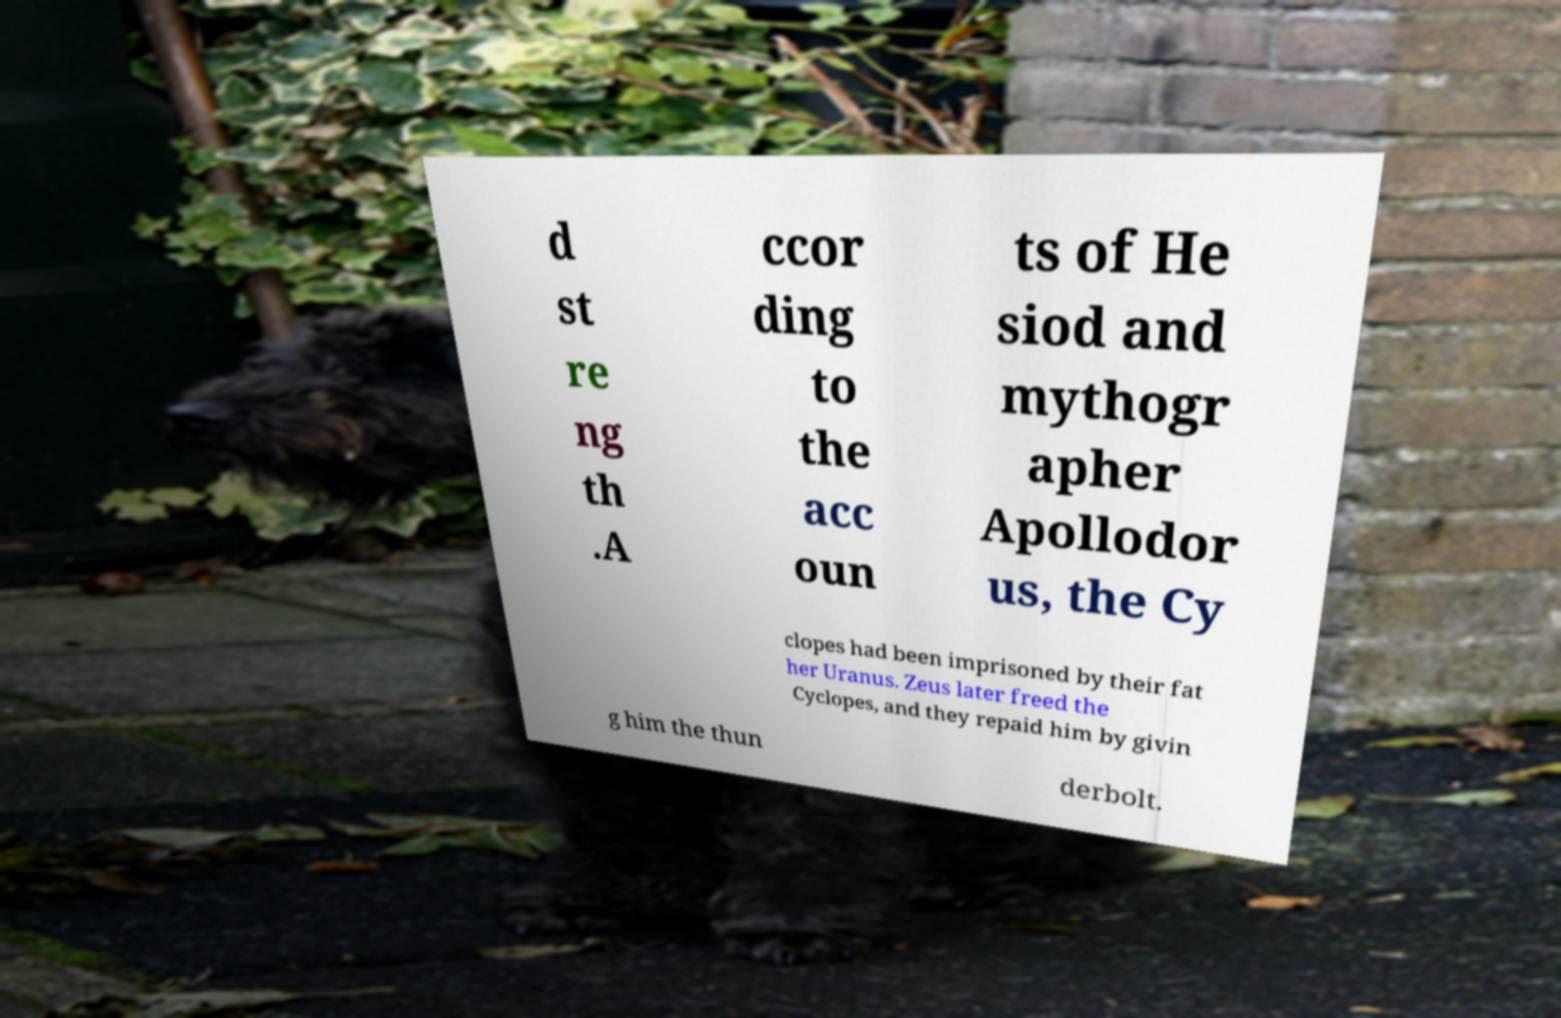Can you accurately transcribe the text from the provided image for me? d st re ng th .A ccor ding to the acc oun ts of He siod and mythogr apher Apollodor us, the Cy clopes had been imprisoned by their fat her Uranus. Zeus later freed the Cyclopes, and they repaid him by givin g him the thun derbolt. 